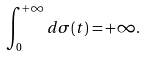<formula> <loc_0><loc_0><loc_500><loc_500>\int _ { 0 } ^ { + \infty } d \sigma ( t ) = + \infty .</formula> 